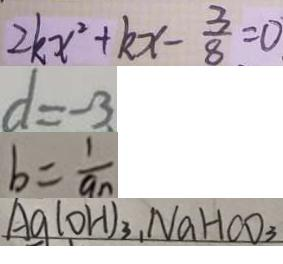Convert formula to latex. <formula><loc_0><loc_0><loc_500><loc_500>2 k x ^ { 2 } + k x - \frac { 3 } { 8 } = 0 
 d = - 3 
 b = \frac { 1 } { a _ { n } } 
 A g ( O H ) _ { 3 } , N a H C O _ { 3 }</formula> 